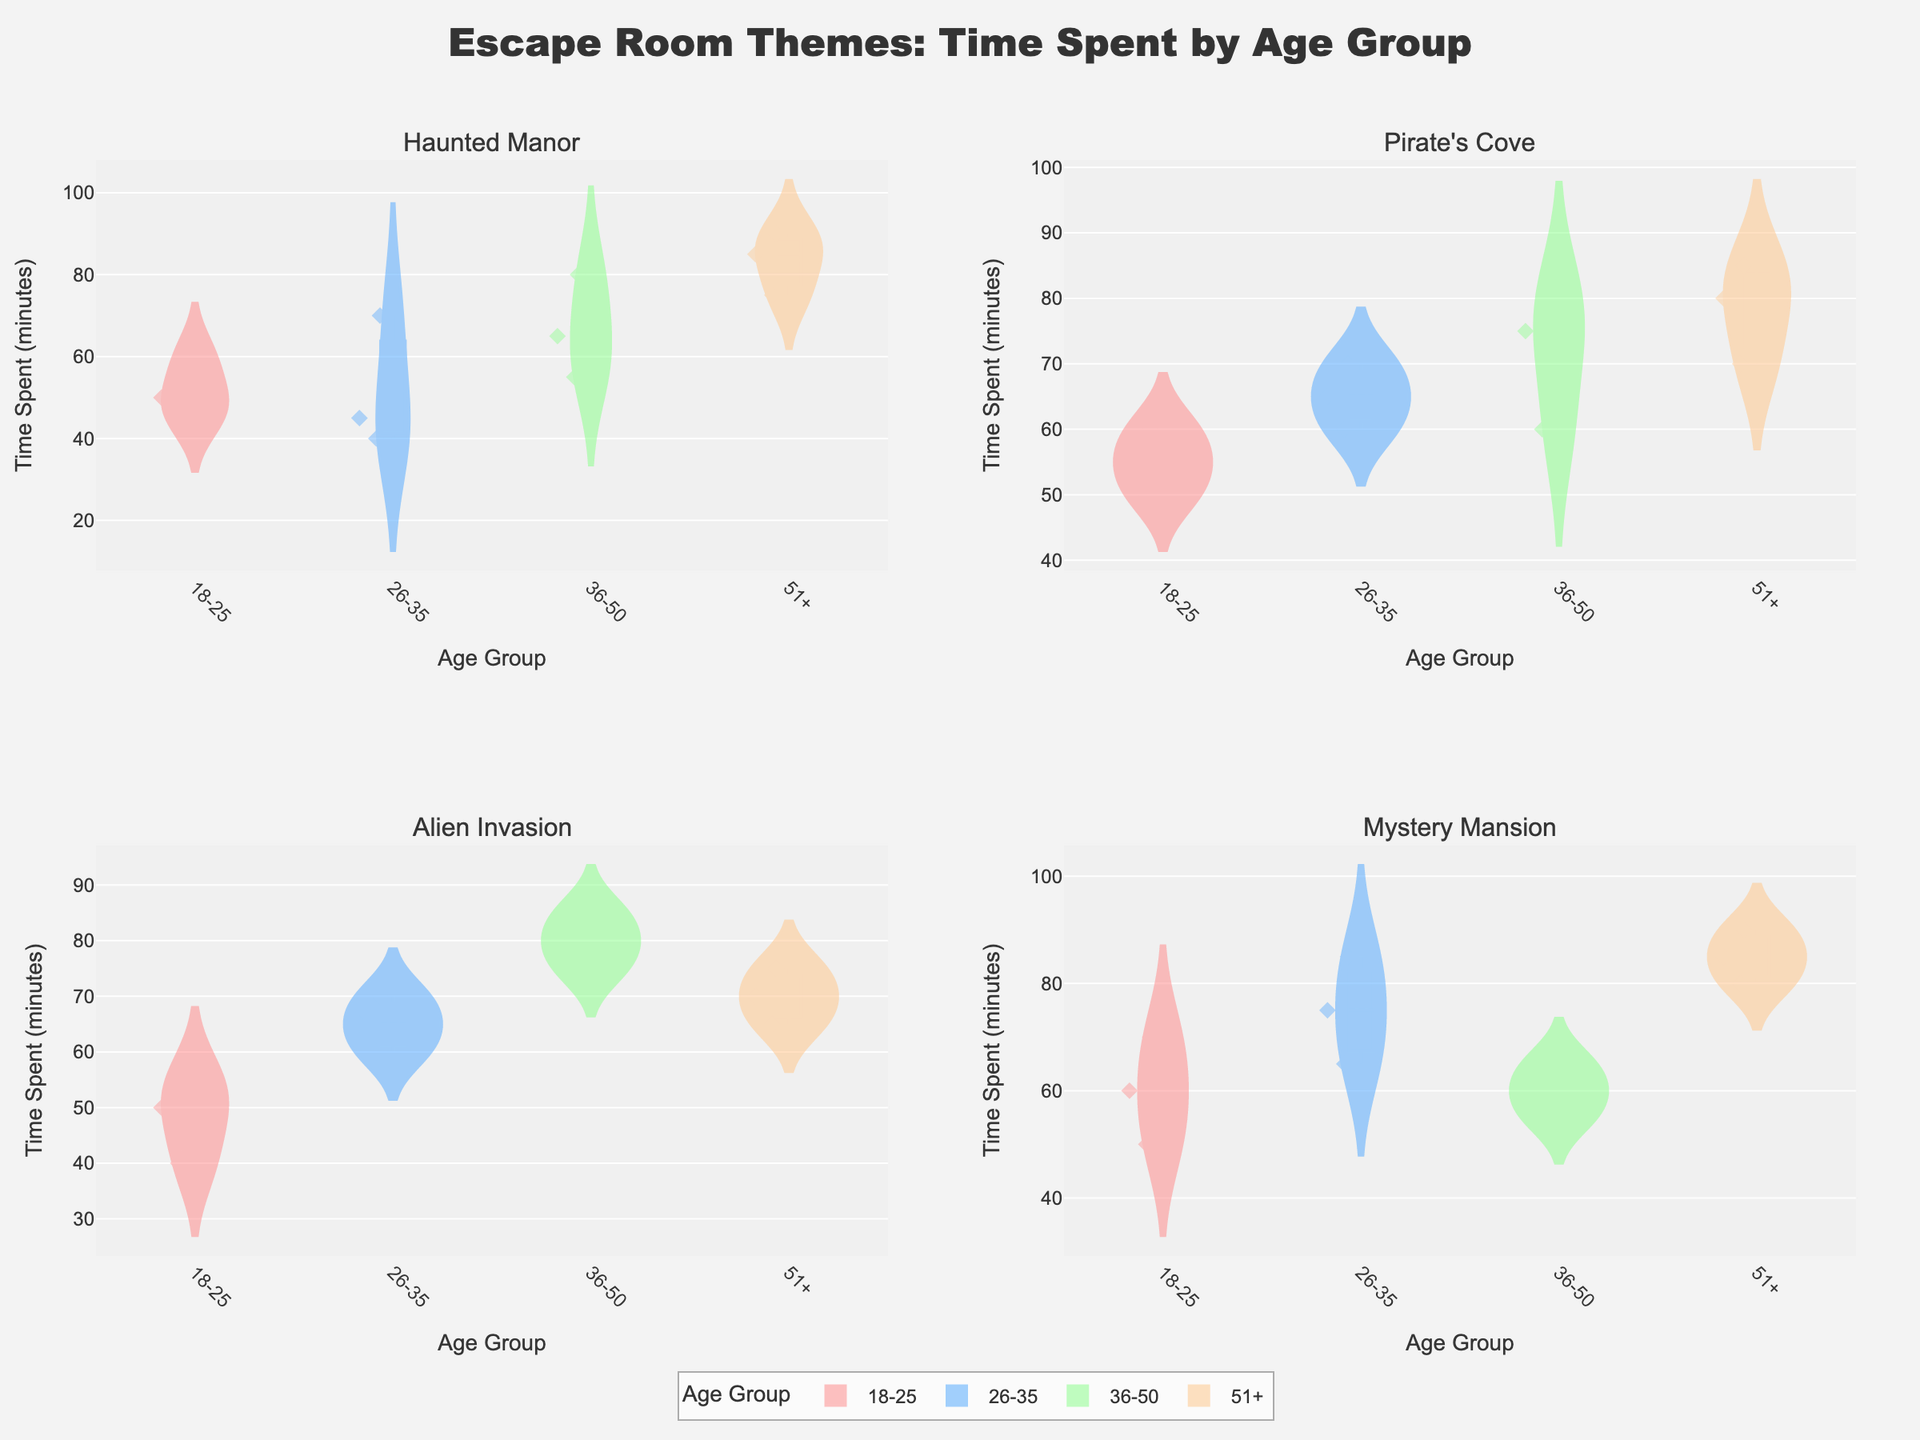How many themes are displayed in the figure? There are four subplot titles displayed in the figure, each corresponding to a different theme: Haunted Manor, Pirate's Cove, Alien Invasion, and Mystery Mansion
Answer: 4 Which age group in the "Haunted Manor" theme spent the most time on average? The age group 51+ in the Haunted Manor theme has the highest average time spent, noticeable by the higher position of their violin plot
Answer: 51+ What is the color used for the 26-35 age group in the violin plots? The 26-35 age group is consistently represented by the same color in each subplot. This color is a shade of light blue.
Answer: Light blue In the "Pirate's Cove" theme, which age group has the widest distribution of time spent? By examining the shape of the violin plots, the 36-50 age group appears to have the widest distribution, as it spans the largest range of time spent values
Answer: 36-50 Compare the median time spent by the 18-25 age group in the "Alien Invasion" and "Mystery Mansion" themes. Which one is higher? The median line within each violin plot shows the central value of data. In the "Alien Invasion" theme, the median time for the 18-25 age group is slightly lower compared to the "Mystery Mansion" theme
Answer: Mystery Mansion Explain the shape of the violin plot in the "Alien Invasion" theme for the 36-50 age group. The violin plot for the 36-50 age group in the "Alien Invasion" theme is tall and narrow, indicating a high concentration of time spent values around the central peak. This suggests that most participants in this age group spent a moderate amount of time in the room, with the times not varying much
Answer: Concentration around a peak What is the overlap of time spent by the 51+ age group in "Haunted Manor" and "Pirate's Cove"? The time spent violin plots for the 51+ age group in both "Haunted Manor" and "Pirate's Cove" show overlap in the range of 70 to 90 minutes, indicating that time spent by this age group falls within this range for both themes
Answer: 70-90 minutes Which subplot shows the highest overall time spent across all age groups? By comparing the maximum values of time spent across all age groups in each subplot, the "Mystery Mansion" theme has the highest overall time spent, reaching up to 90 minutes
Answer: Mystery Mansion Identify the age group with the least amount of variation in the "Mystery Mansion" subplot. The violin plot for the 36-50 age group in the "Mystery Mansion" theme is the least spread out, indicating the smallest variation in time spent within this age group
Answer: 36-50 How does the mean time spent by the 26-35 age group in "Pirate's Cove" compare to "Alien Invasion"? The mean line (visible within the violin plots) is slightly higher in the "Pirate's Cove" theme compared to the "Alien Invasion" theme for the 26-35 age group, indicating a higher mean time spent
Answer: Pirate's Cove 